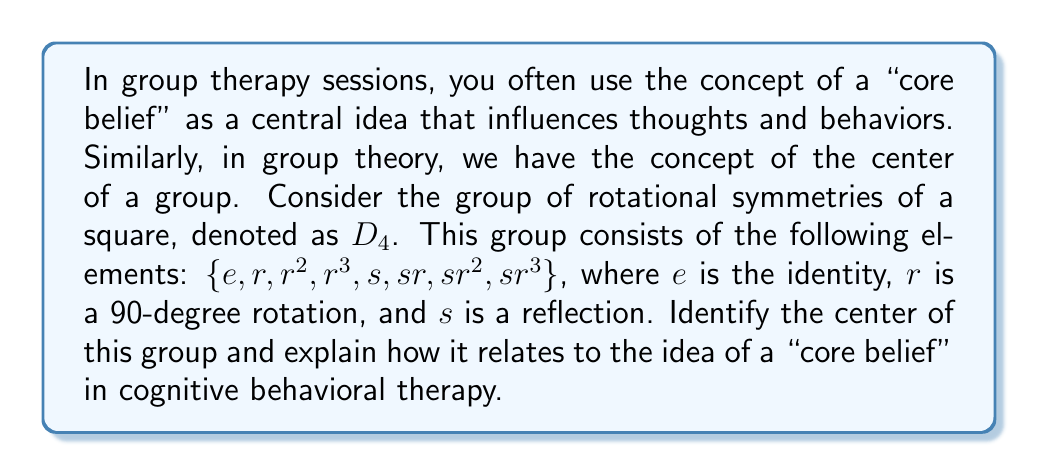Teach me how to tackle this problem. To find the center of the group $D_4$, we need to identify the elements that commute with every other element in the group. Let's approach this step-by-step:

1. Recall the definition of the center: The center $Z(G)$ of a group $G$ is the set of all elements in $G$ that commute with every element of $G$. Mathematically,
   $$Z(G) = \{z \in G : zg = gz \text{ for all } g \in G\}$$

2. We know that the identity element $e$ always commutes with every element, so $e$ is always in the center.

3. Let's check the rotations:
   - $r$ doesn't commute with $s$, as $rs \neq sr$
   - $r^2$ commutes with everything (180-degree rotation)
   - $r^3$ doesn't commute with $s$, as $r^3s \neq sr^3$

4. The reflections $s, sr, sr^2, sr^3$ don't commute with the rotations.

5. Therefore, the center of $D_4$ is $Z(D_4) = \{e, r^2\}$

Relating this to cognitive behavioral therapy:

Just as the center of a group contains elements that "work harmoniously" with all other elements, core beliefs in CBT are central ideas that influence all aspects of a person's thoughts and behaviors. The center elements ($e$ and $r^2$) can be seen as analogous to fundamental, deeply-held beliefs that remain consistent regardless of the situation (represented by other group elements).

The fact that the center is a proper subgroup of $D_4$ aligns with the idea that core beliefs are a subset of all beliefs and thoughts a person might have. Just as the center elements have special properties within the group, core beliefs have a special role in shaping a person's cognitive and behavioral patterns.
Answer: The center of the group $D_4$ is $Z(D_4) = \{e, r^2\}$, where $e$ is the identity and $r^2$ is a 180-degree rotation. 